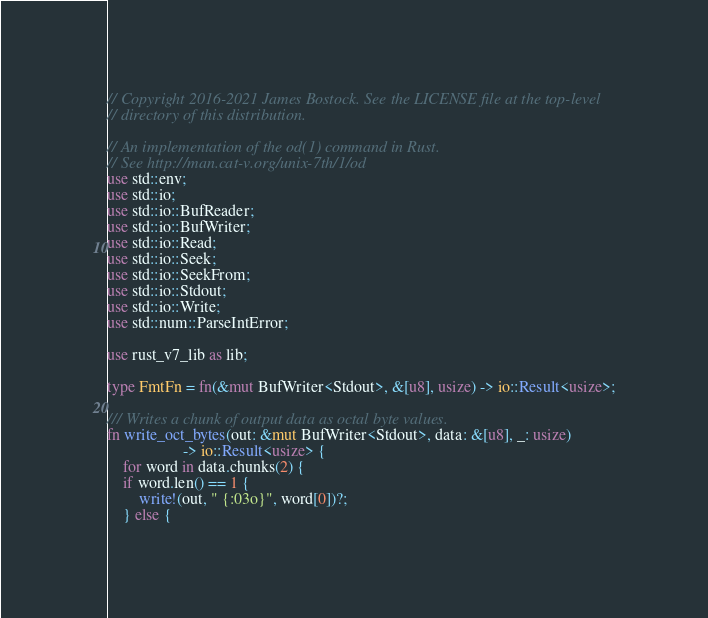<code> <loc_0><loc_0><loc_500><loc_500><_Rust_>// Copyright 2016-2021 James Bostock. See the LICENSE file at the top-level
// directory of this distribution.

// An implementation of the od(1) command in Rust.
// See http://man.cat-v.org/unix-7th/1/od
use std::env;
use std::io;
use std::io::BufReader;
use std::io::BufWriter;
use std::io::Read;
use std::io::Seek;
use std::io::SeekFrom;
use std::io::Stdout;
use std::io::Write;
use std::num::ParseIntError;

use rust_v7_lib as lib;

type FmtFn = fn(&mut BufWriter<Stdout>, &[u8], usize) -> io::Result<usize>;

/// Writes a chunk of output data as octal byte values.
fn write_oct_bytes(out: &mut BufWriter<Stdout>, data: &[u8], _: usize)
                   -> io::Result<usize> {
    for word in data.chunks(2) {
	if word.len() == 1 {
	    write!(out, " {:03o}", word[0])?;
	} else {</code> 